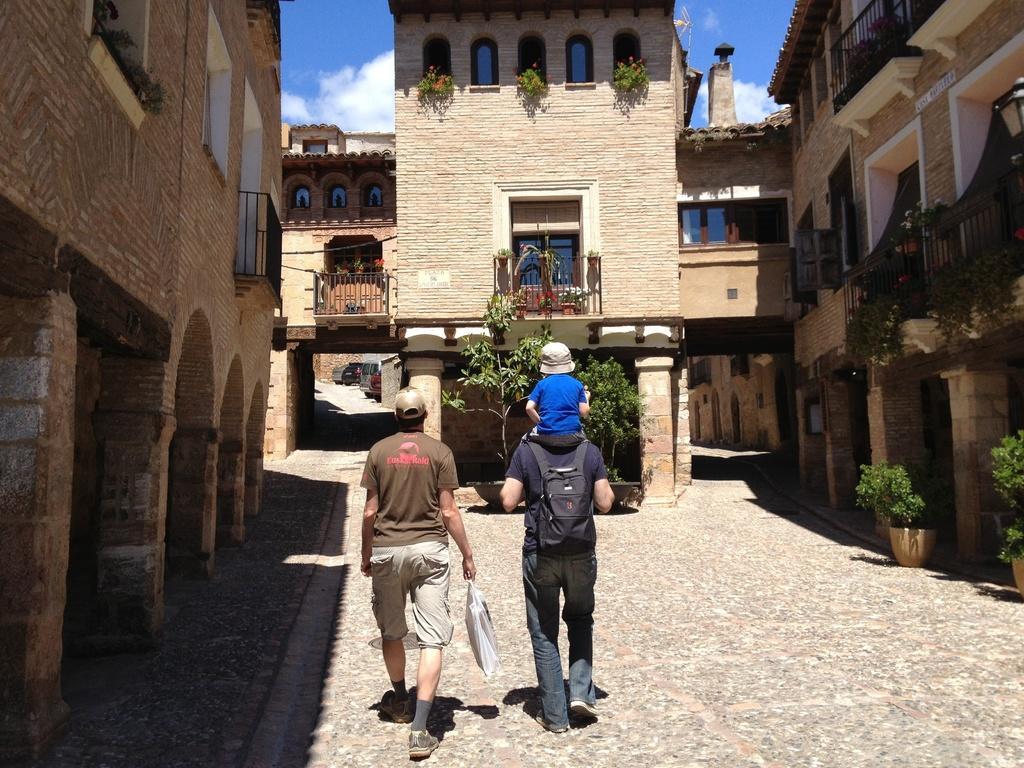Describe this image in one or two sentences. In this image I can see two persons walking. The person at left wearing brown shirt, cream pant and the person at right wearing blue shirt, gray pant and black bag. Background I can see trees in green color, building in cream color and sky in blue and white color. 